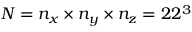Convert formula to latex. <formula><loc_0><loc_0><loc_500><loc_500>N = n _ { x } \times n _ { y } \times n _ { z } = 2 2 ^ { 3 }</formula> 